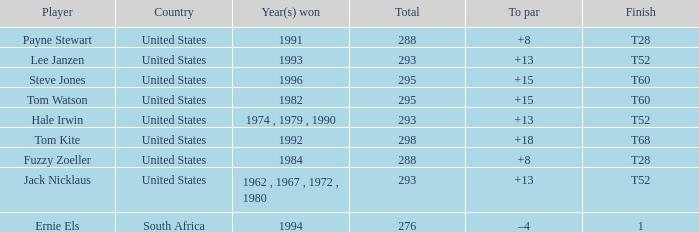Who is the player who won in 1994? Ernie Els. 